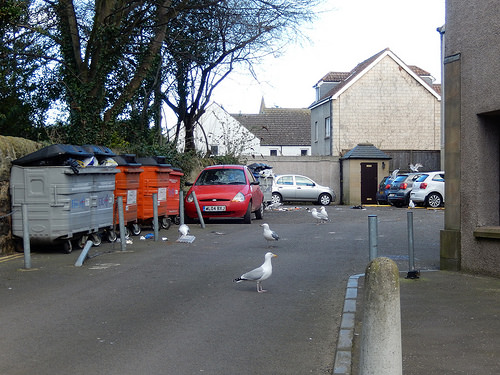<image>
Is the garbage can on the trash? No. The garbage can is not positioned on the trash. They may be near each other, but the garbage can is not supported by or resting on top of the trash. Where is the bird in relation to the car? Is it in front of the car? Yes. The bird is positioned in front of the car, appearing closer to the camera viewpoint. 